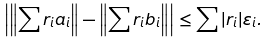Convert formula to latex. <formula><loc_0><loc_0><loc_500><loc_500>\left | \left \| \sum r _ { i } a _ { i } \right \| - \left \| \sum r _ { i } b _ { i } \right \| \right | \leq \sum | r _ { i } | \varepsilon _ { i } .</formula> 